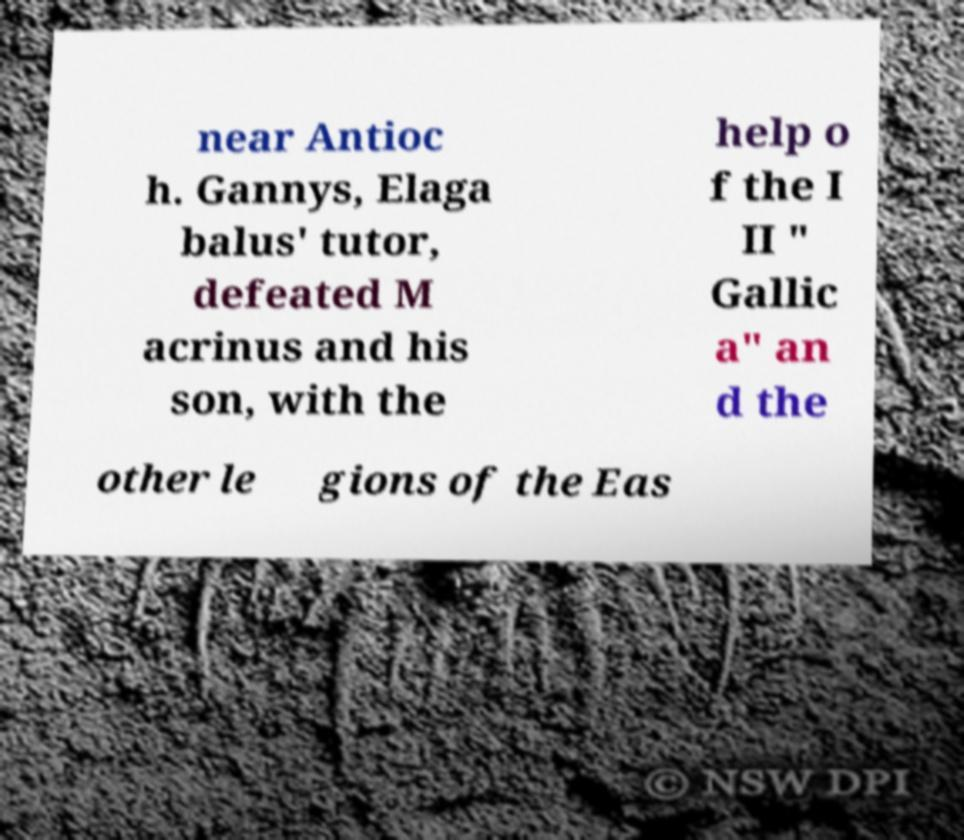Could you assist in decoding the text presented in this image and type it out clearly? near Antioc h. Gannys, Elaga balus' tutor, defeated M acrinus and his son, with the help o f the I II " Gallic a" an d the other le gions of the Eas 